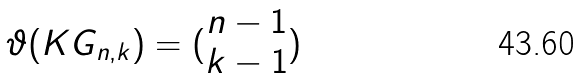Convert formula to latex. <formula><loc_0><loc_0><loc_500><loc_500>\vartheta ( K G _ { n , k } ) = ( \begin{matrix} n - 1 \\ k - 1 \end{matrix} )</formula> 